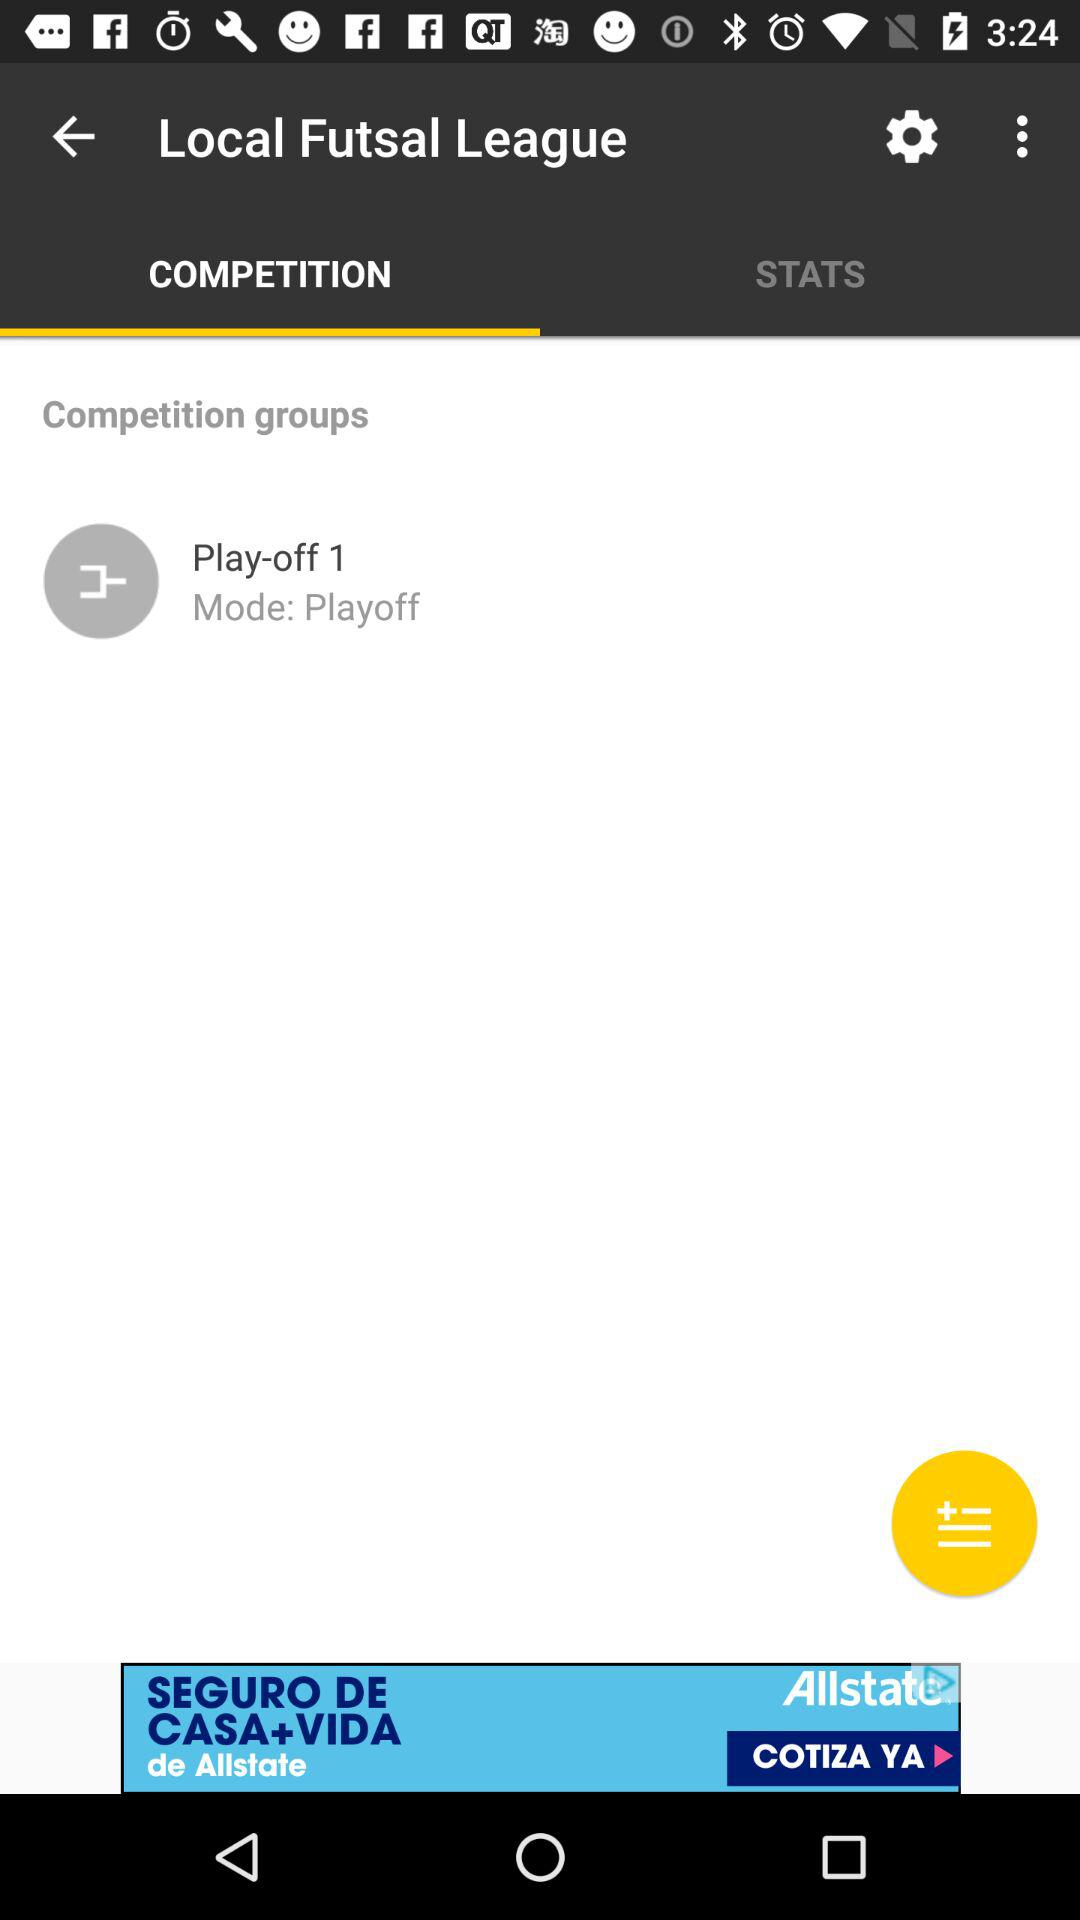Which tab is selected? The selected tab is "COMPETITION". 